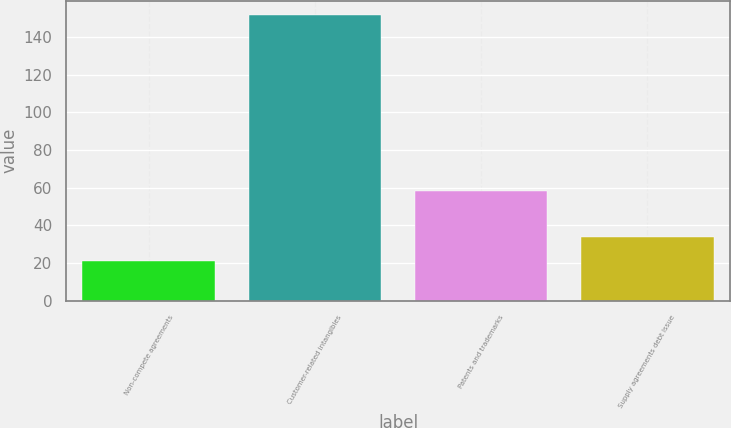Convert chart to OTSL. <chart><loc_0><loc_0><loc_500><loc_500><bar_chart><fcel>Non-compete agreements<fcel>Customer-related intangibles<fcel>Patents and trademarks<fcel>Supply agreements debt issue<nl><fcel>20.9<fcel>151.6<fcel>58.4<fcel>33.97<nl></chart> 